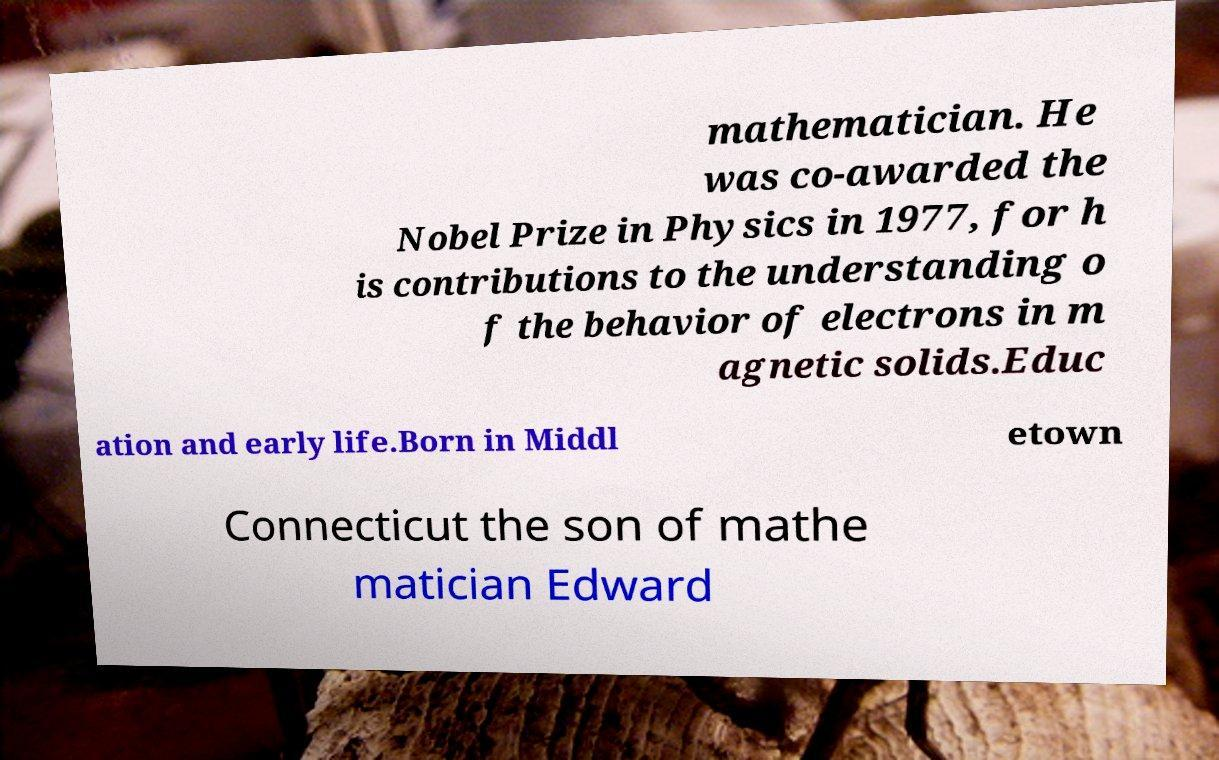Could you assist in decoding the text presented in this image and type it out clearly? mathematician. He was co-awarded the Nobel Prize in Physics in 1977, for h is contributions to the understanding o f the behavior of electrons in m agnetic solids.Educ ation and early life.Born in Middl etown Connecticut the son of mathe matician Edward 